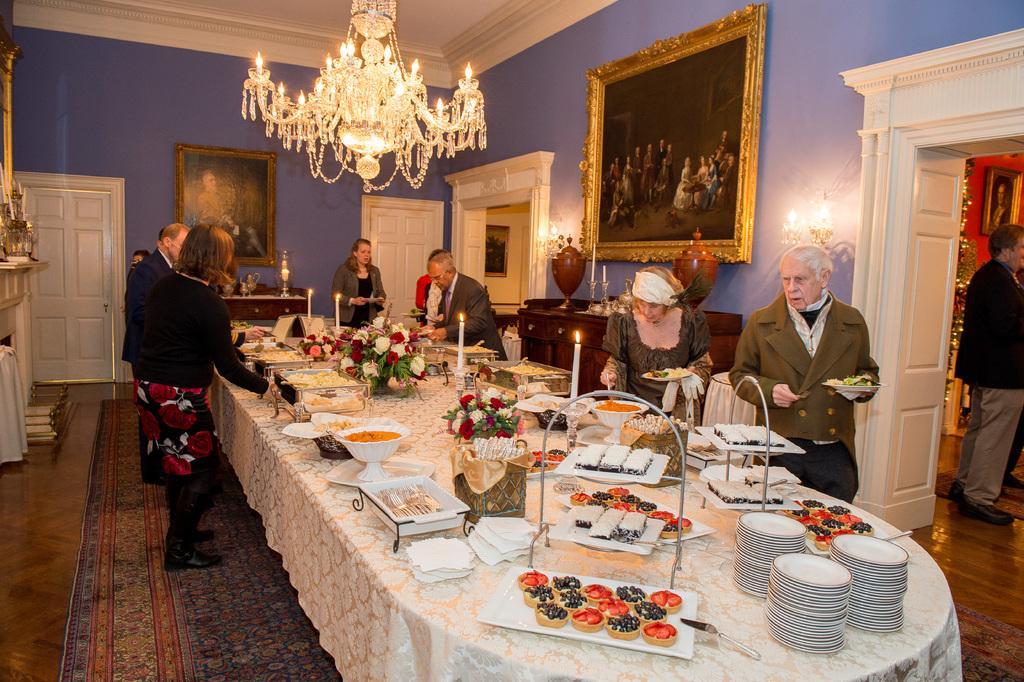Can you describe this image briefly? This image is clicked inside a room. There is a table in the center of the room. On the table there are flower vases, candles on the candle holders, plates, bowls, tissues and food. There are people around the table and they are serving food. In the background there is a wall. There are picture frames on the wall. There is a chandelier hanging to the ceiling. There is a carpet on the floor. To the right there is a man standing in the next room. 